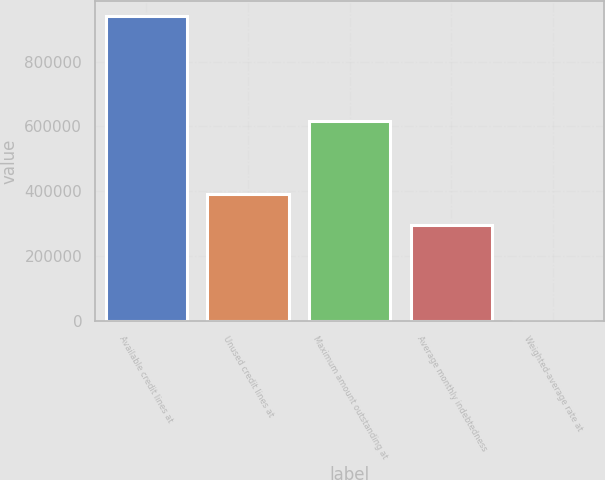Convert chart to OTSL. <chart><loc_0><loc_0><loc_500><loc_500><bar_chart><fcel>Available credit lines at<fcel>Unused credit lines at<fcel>Maximum amount outstanding at<fcel>Average monthly indebtedness<fcel>Weighted-average rate at<nl><fcel>940000<fcel>391000<fcel>616000<fcel>297000<fcel>2.74<nl></chart> 